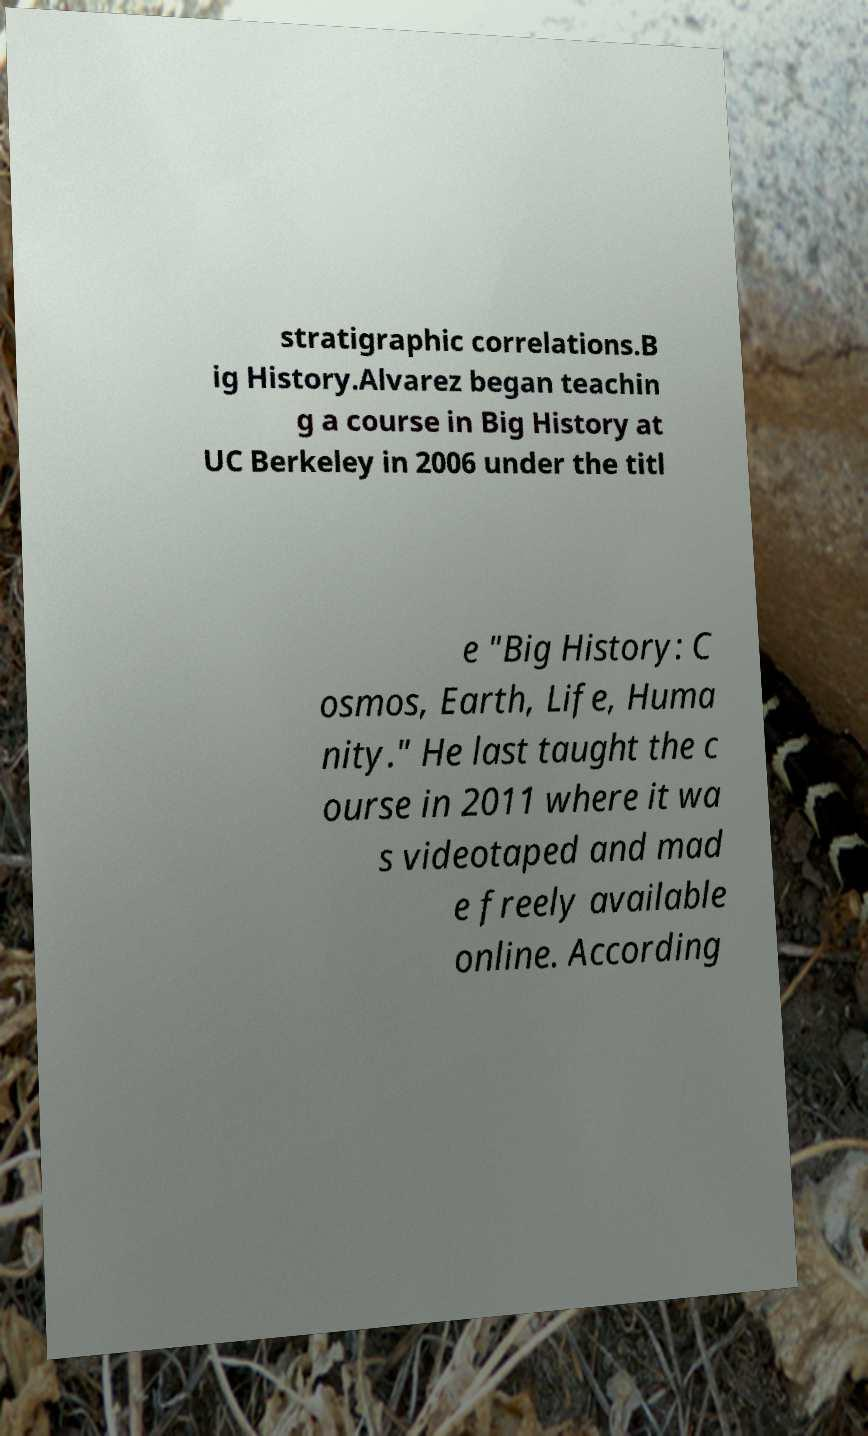Please read and relay the text visible in this image. What does it say? stratigraphic correlations.B ig History.Alvarez began teachin g a course in Big History at UC Berkeley in 2006 under the titl e "Big History: C osmos, Earth, Life, Huma nity." He last taught the c ourse in 2011 where it wa s videotaped and mad e freely available online. According 